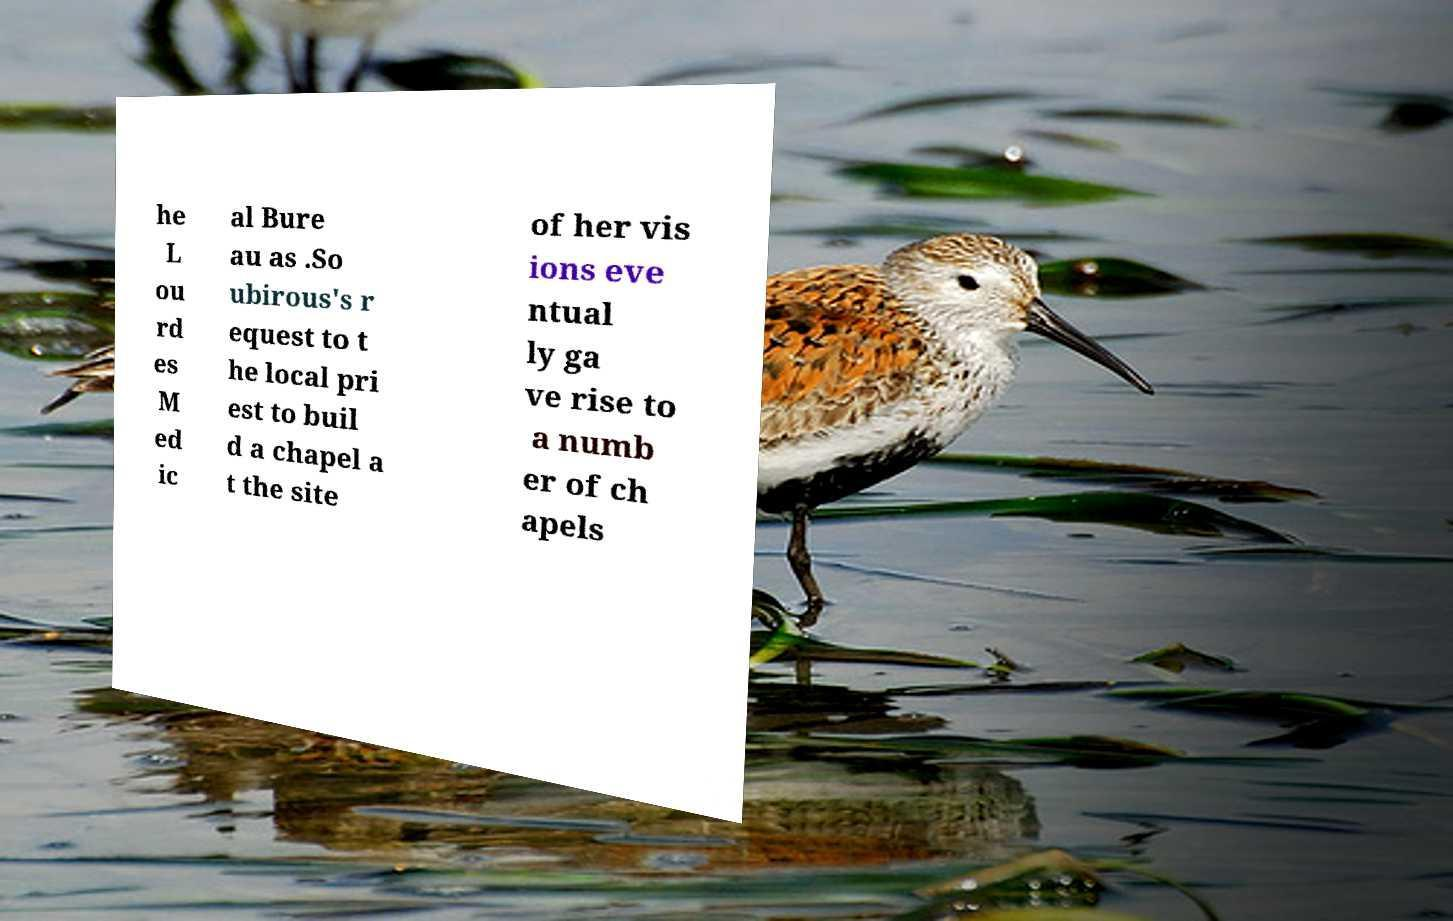I need the written content from this picture converted into text. Can you do that? he L ou rd es M ed ic al Bure au as .So ubirous's r equest to t he local pri est to buil d a chapel a t the site of her vis ions eve ntual ly ga ve rise to a numb er of ch apels 